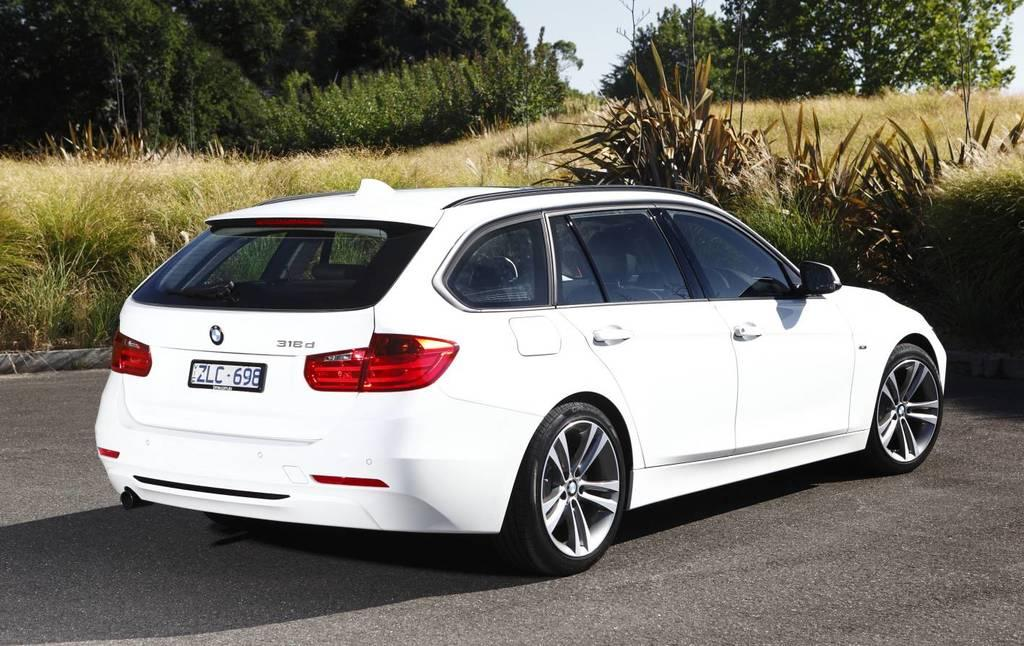Provide a one-sentence caption for the provided image. A white BMW with license plate, ZLC - 698, parked near a brushy area on the side of a street. 